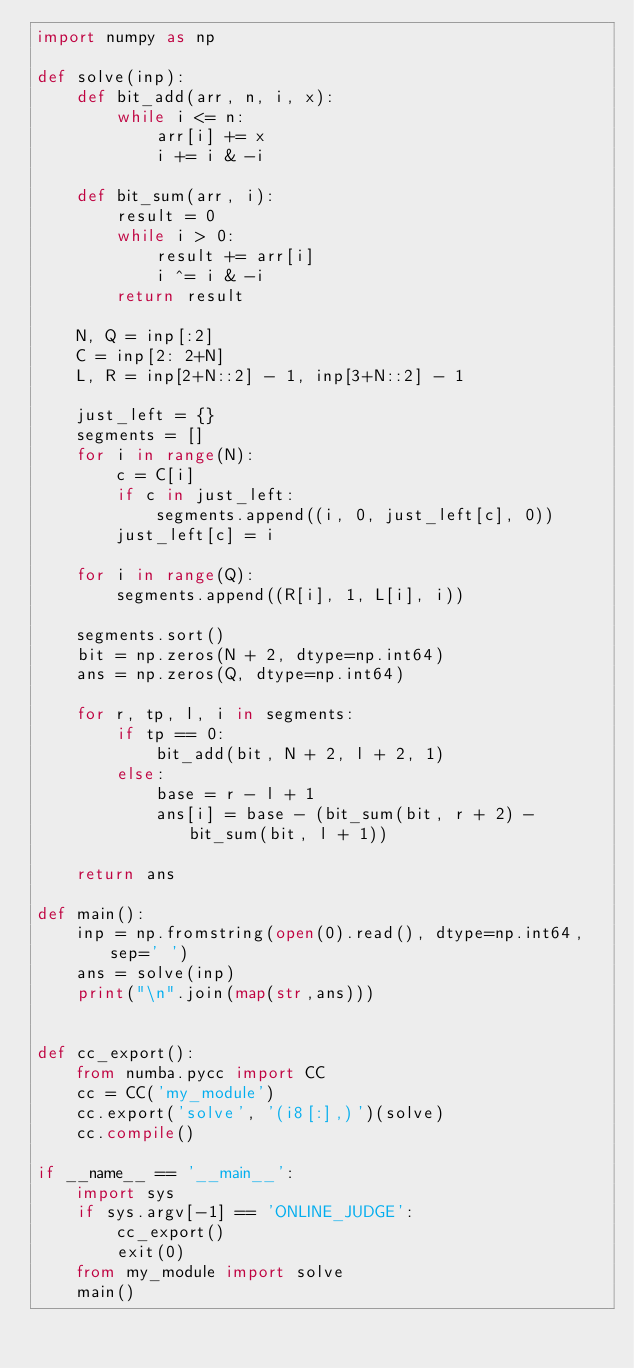Convert code to text. <code><loc_0><loc_0><loc_500><loc_500><_Python_>import numpy as np

def solve(inp):
    def bit_add(arr, n, i, x):
        while i <= n:
            arr[i] += x
            i += i & -i

    def bit_sum(arr, i):
        result = 0
        while i > 0:
            result += arr[i]
            i ^= i & -i
        return result

    N, Q = inp[:2]
    C = inp[2: 2+N]
    L, R = inp[2+N::2] - 1, inp[3+N::2] - 1

    just_left = {}
    segments = []
    for i in range(N):
        c = C[i]
        if c in just_left:
            segments.append((i, 0, just_left[c], 0))
        just_left[c] = i

    for i in range(Q):
        segments.append((R[i], 1, L[i], i))

    segments.sort()
    bit = np.zeros(N + 2, dtype=np.int64)
    ans = np.zeros(Q, dtype=np.int64)

    for r, tp, l, i in segments:
        if tp == 0:
            bit_add(bit, N + 2, l + 2, 1)
        else:
            base = r - l + 1
            ans[i] = base - (bit_sum(bit, r + 2) - bit_sum(bit, l + 1))

    return ans

def main():
    inp = np.fromstring(open(0).read(), dtype=np.int64, sep=' ')
    ans = solve(inp)
    print("\n".join(map(str,ans)))
    

def cc_export():
    from numba.pycc import CC
    cc = CC('my_module')
    cc.export('solve', '(i8[:],)')(solve)
    cc.compile()

if __name__ == '__main__':
    import sys
    if sys.argv[-1] == 'ONLINE_JUDGE':
        cc_export()
        exit(0)
    from my_module import solve
    main()</code> 